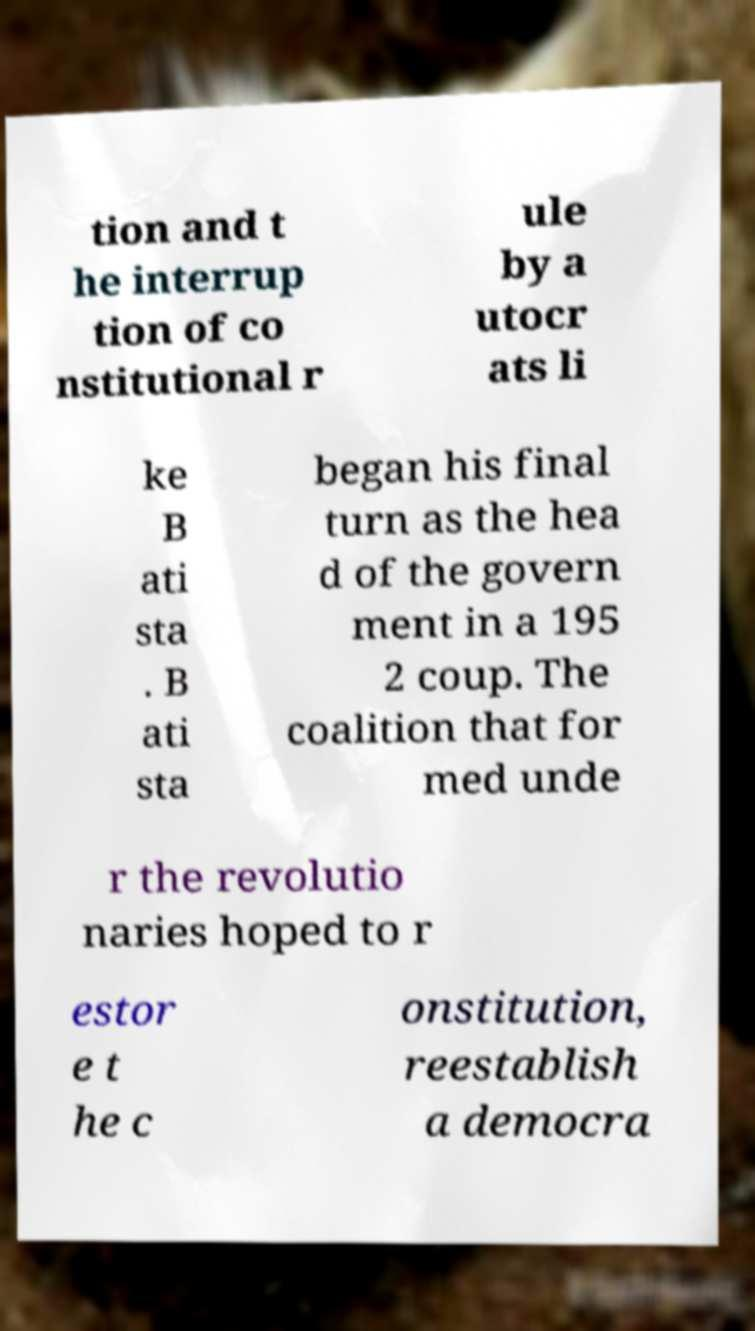Can you read and provide the text displayed in the image?This photo seems to have some interesting text. Can you extract and type it out for me? tion and t he interrup tion of co nstitutional r ule by a utocr ats li ke B ati sta . B ati sta began his final turn as the hea d of the govern ment in a 195 2 coup. The coalition that for med unde r the revolutio naries hoped to r estor e t he c onstitution, reestablish a democra 